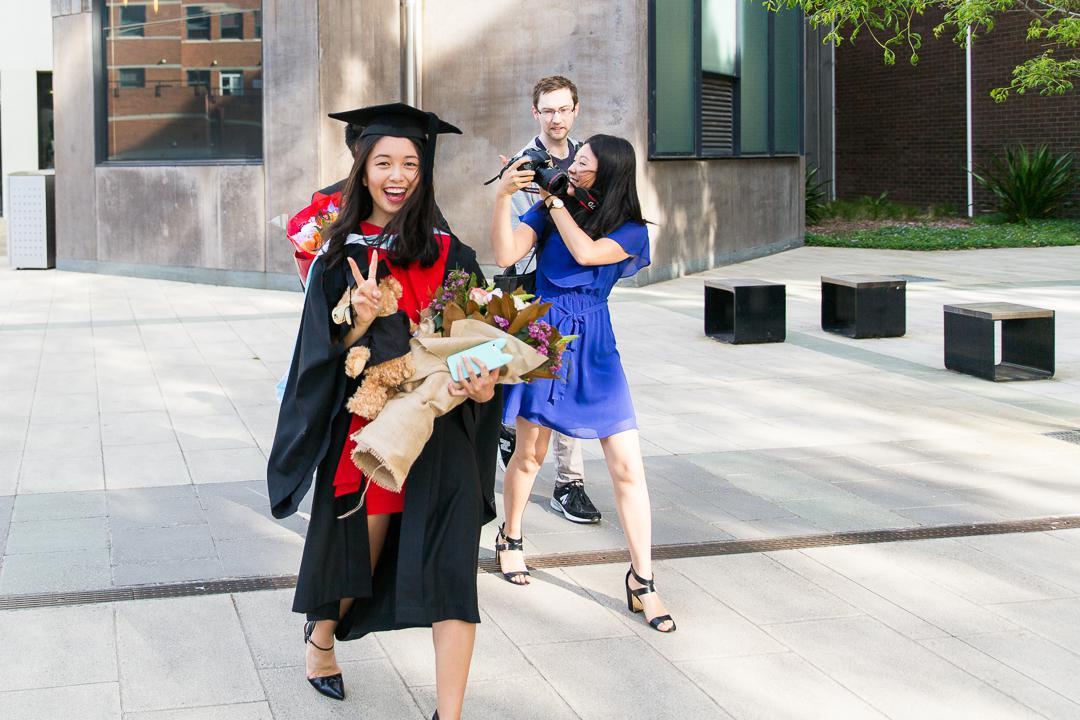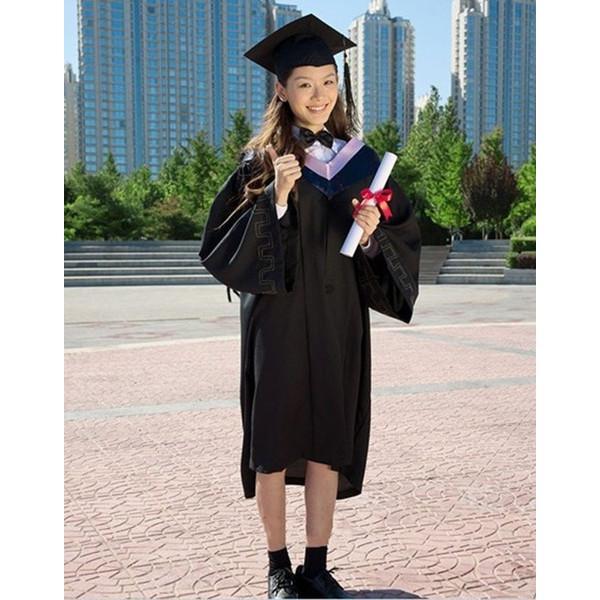The first image is the image on the left, the second image is the image on the right. Considering the images on both sides, is "In each image, a woman with long dark hair is wearing a black graduation gown and mortarboard and black shoes in an outdoor setting." valid? Answer yes or no. Yes. The first image is the image on the left, the second image is the image on the right. Analyze the images presented: Is the assertion "A single male is posing in graduation attire in the image on the right." valid? Answer yes or no. No. 